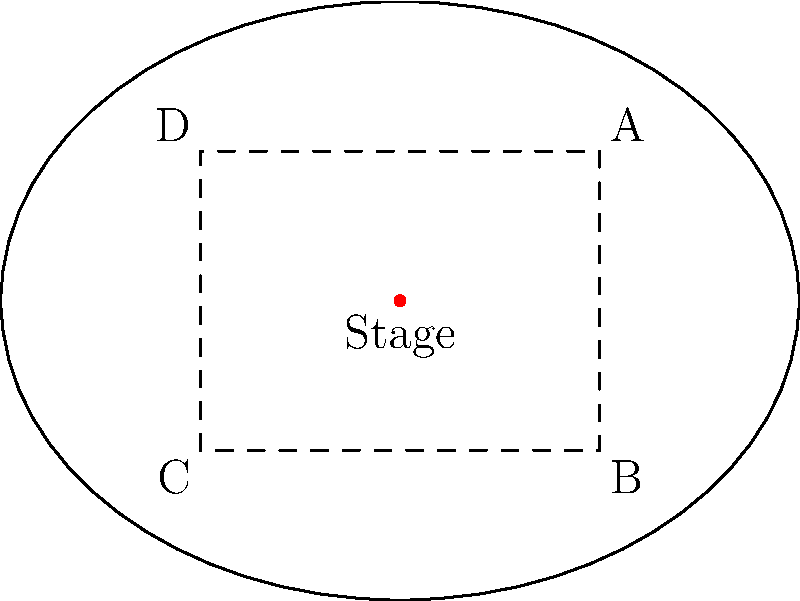In an elliptical concert hall designed for Beethoven's symphonies, the stage is located at the center. The hall's dimensions are 80 meters along the major axis and 60 meters along the minor axis. A rectangular seating area ABCD is planned within the hall, with sides parallel to the axes. If the distance from each side of the rectangle to the nearest point on the ellipse is 10 meters, what is the area of the rectangular seating section in square meters? Let's approach this step-by-step:

1) The ellipse's semi-major axis is 40 meters (half of 80), and the semi-minor axis is 30 meters (half of 60).

2) The rectangle ABCD is positioned 10 meters from the edge of the ellipse on all sides.

3) This means that the length of the rectangle along the major axis is:
   $80 - (2 * 10) = 60$ meters

4) And the width of the rectangle along the minor axis is:
   $60 - (2 * 10) = 40$ meters

5) To calculate the area of a rectangle, we multiply its length by its width:

   Area $= 60 * 40 = 2400$ square meters

Therefore, the rectangular seating area ABCD has an area of 2400 square meters.
Answer: 2400 square meters 